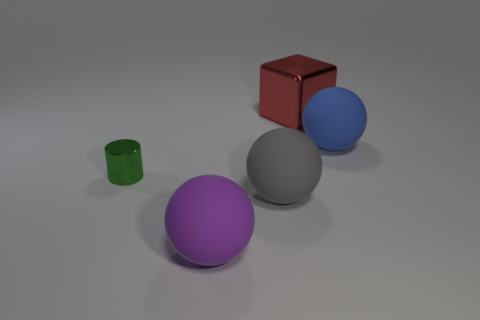Add 4 gray shiny cubes. How many objects exist? 9 Subtract all spheres. How many objects are left? 2 Subtract 0 yellow balls. How many objects are left? 5 Subtract all big red objects. Subtract all red objects. How many objects are left? 3 Add 1 tiny cylinders. How many tiny cylinders are left? 2 Add 4 cylinders. How many cylinders exist? 5 